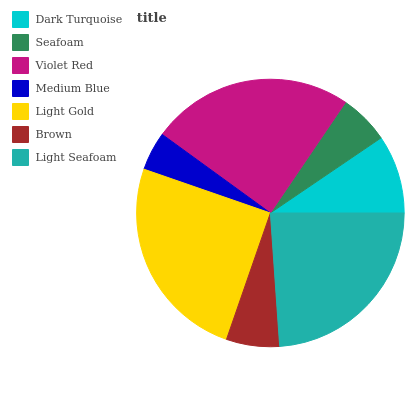Is Medium Blue the minimum?
Answer yes or no. Yes. Is Light Gold the maximum?
Answer yes or no. Yes. Is Seafoam the minimum?
Answer yes or no. No. Is Seafoam the maximum?
Answer yes or no. No. Is Dark Turquoise greater than Seafoam?
Answer yes or no. Yes. Is Seafoam less than Dark Turquoise?
Answer yes or no. Yes. Is Seafoam greater than Dark Turquoise?
Answer yes or no. No. Is Dark Turquoise less than Seafoam?
Answer yes or no. No. Is Dark Turquoise the high median?
Answer yes or no. Yes. Is Dark Turquoise the low median?
Answer yes or no. Yes. Is Brown the high median?
Answer yes or no. No. Is Violet Red the low median?
Answer yes or no. No. 